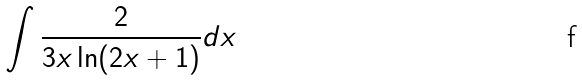<formula> <loc_0><loc_0><loc_500><loc_500>\int \frac { 2 } { 3 x \ln ( 2 x + 1 ) } d x</formula> 